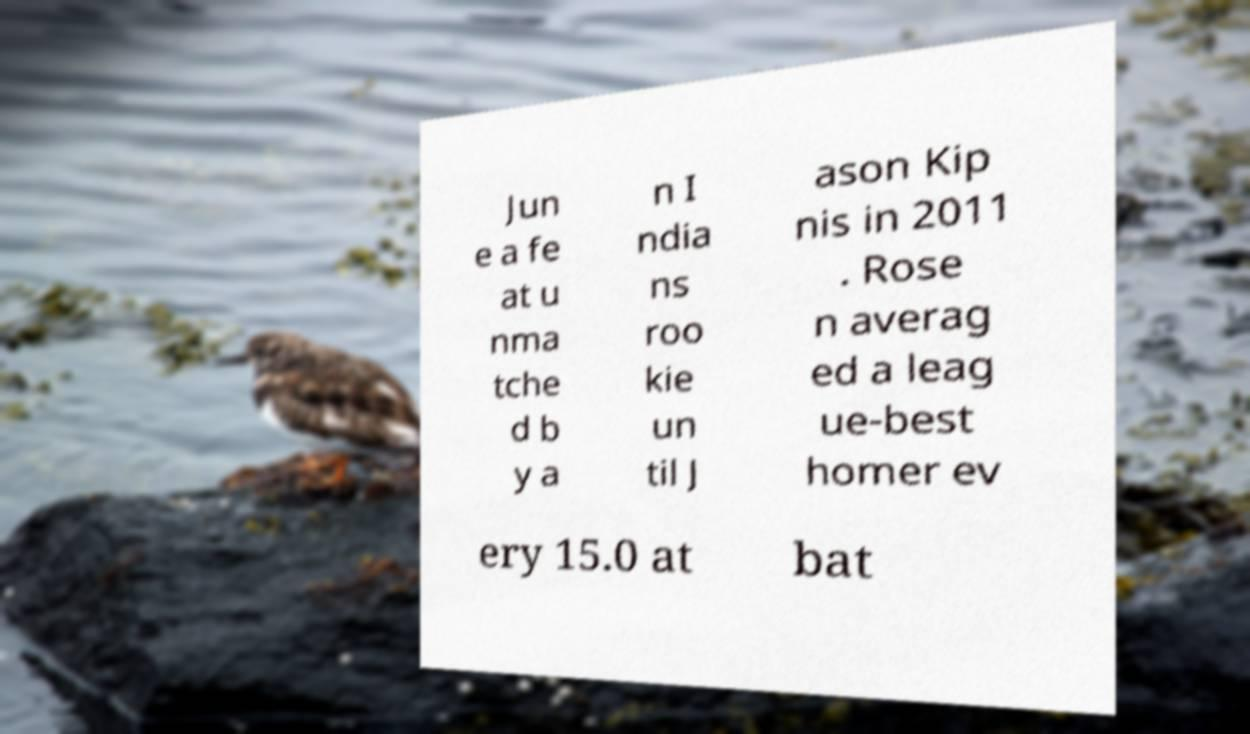Could you assist in decoding the text presented in this image and type it out clearly? Jun e a fe at u nma tche d b y a n I ndia ns roo kie un til J ason Kip nis in 2011 . Rose n averag ed a leag ue-best homer ev ery 15.0 at bat 